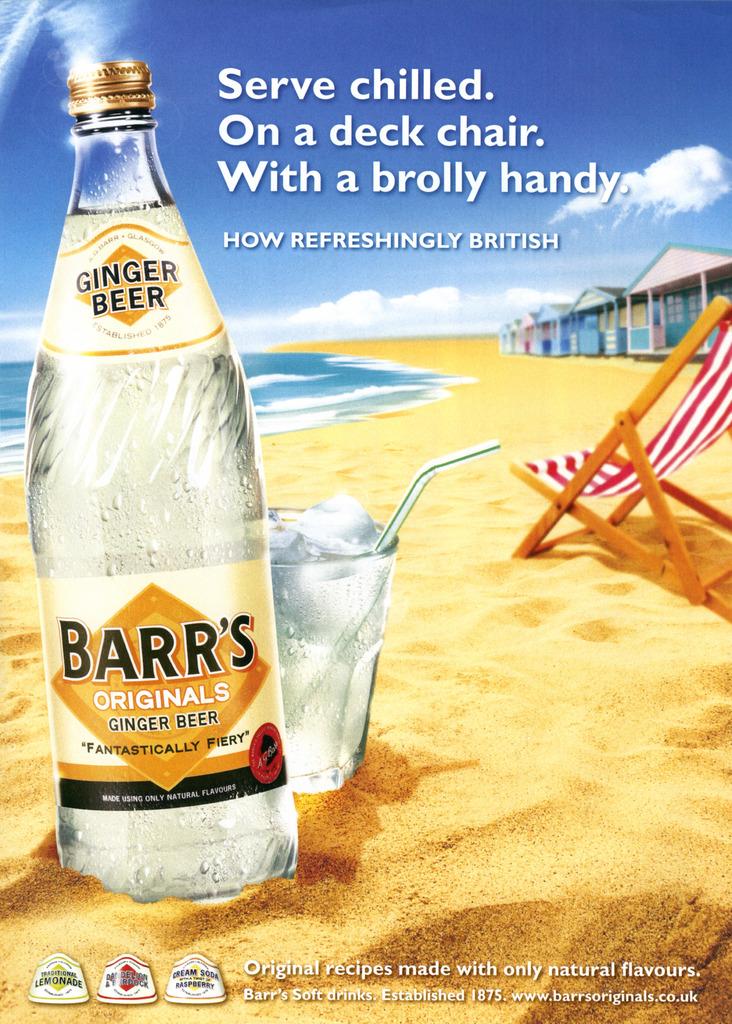What kind of beer is featured?
Your response must be concise. Ginger. What brand of beer is this?
Your response must be concise. Barr's. 